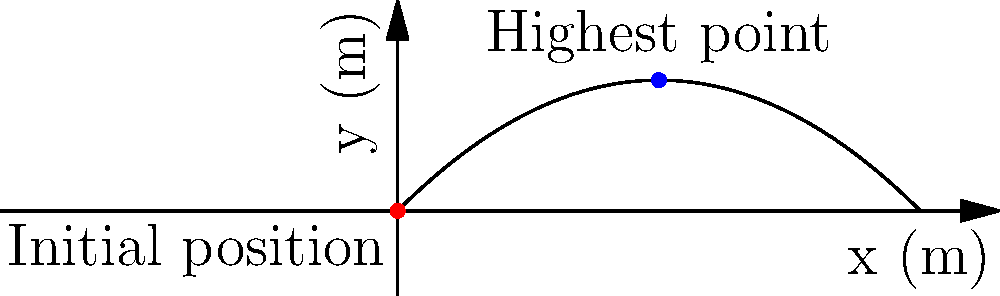An athlete from Saudi Arabia is practicing for an international competition in Canada. He throws a shot put with an initial velocity of $20$ m/s at an angle of $45^\circ$ to the horizontal. Assuming air resistance is negligible, what is the maximum height reached by the shot put? To find the maximum height, we can follow these steps:

1) The initial velocity components are:
   $v_{0x} = v_0 \cos \theta = 20 \cos 45^\circ = 20 \cdot \frac{\sqrt{2}}{2} \approx 14.14$ m/s
   $v_{0y} = v_0 \sin \theta = 20 \sin 45^\circ = 20 \cdot \frac{\sqrt{2}}{2} \approx 14.14$ m/s

2) The time to reach the maximum height is when the vertical velocity becomes zero:
   $v_y = v_{0y} - gt = 0$
   $t = \frac{v_{0y}}{g} = \frac{14.14}{9.8} \approx 1.44$ s

3) The maximum height can be calculated using the equation:
   $y = v_{0y}t - \frac{1}{2}gt^2$

4) Substituting the values:
   $y_{max} = 14.14 \cdot 1.44 - \frac{1}{2} \cdot 9.8 \cdot 1.44^2$
   $y_{max} = 20.36 - 10.18 = 10.18$ m

Therefore, the maximum height reached by the shot put is approximately 10.18 meters.
Answer: 10.18 m 